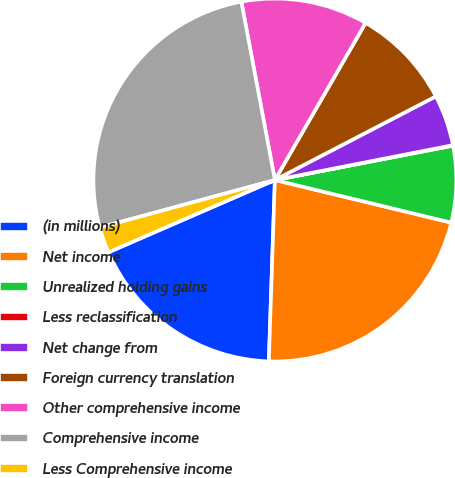Convert chart to OTSL. <chart><loc_0><loc_0><loc_500><loc_500><pie_chart><fcel>(in millions)<fcel>Net income<fcel>Unrealized holding gains<fcel>Less reclassification<fcel>Net change from<fcel>Foreign currency translation<fcel>Other comprehensive income<fcel>Comprehensive income<fcel>Less Comprehensive income<nl><fcel>17.95%<fcel>21.76%<fcel>6.8%<fcel>0.05%<fcel>4.55%<fcel>9.04%<fcel>11.29%<fcel>26.26%<fcel>2.3%<nl></chart> 